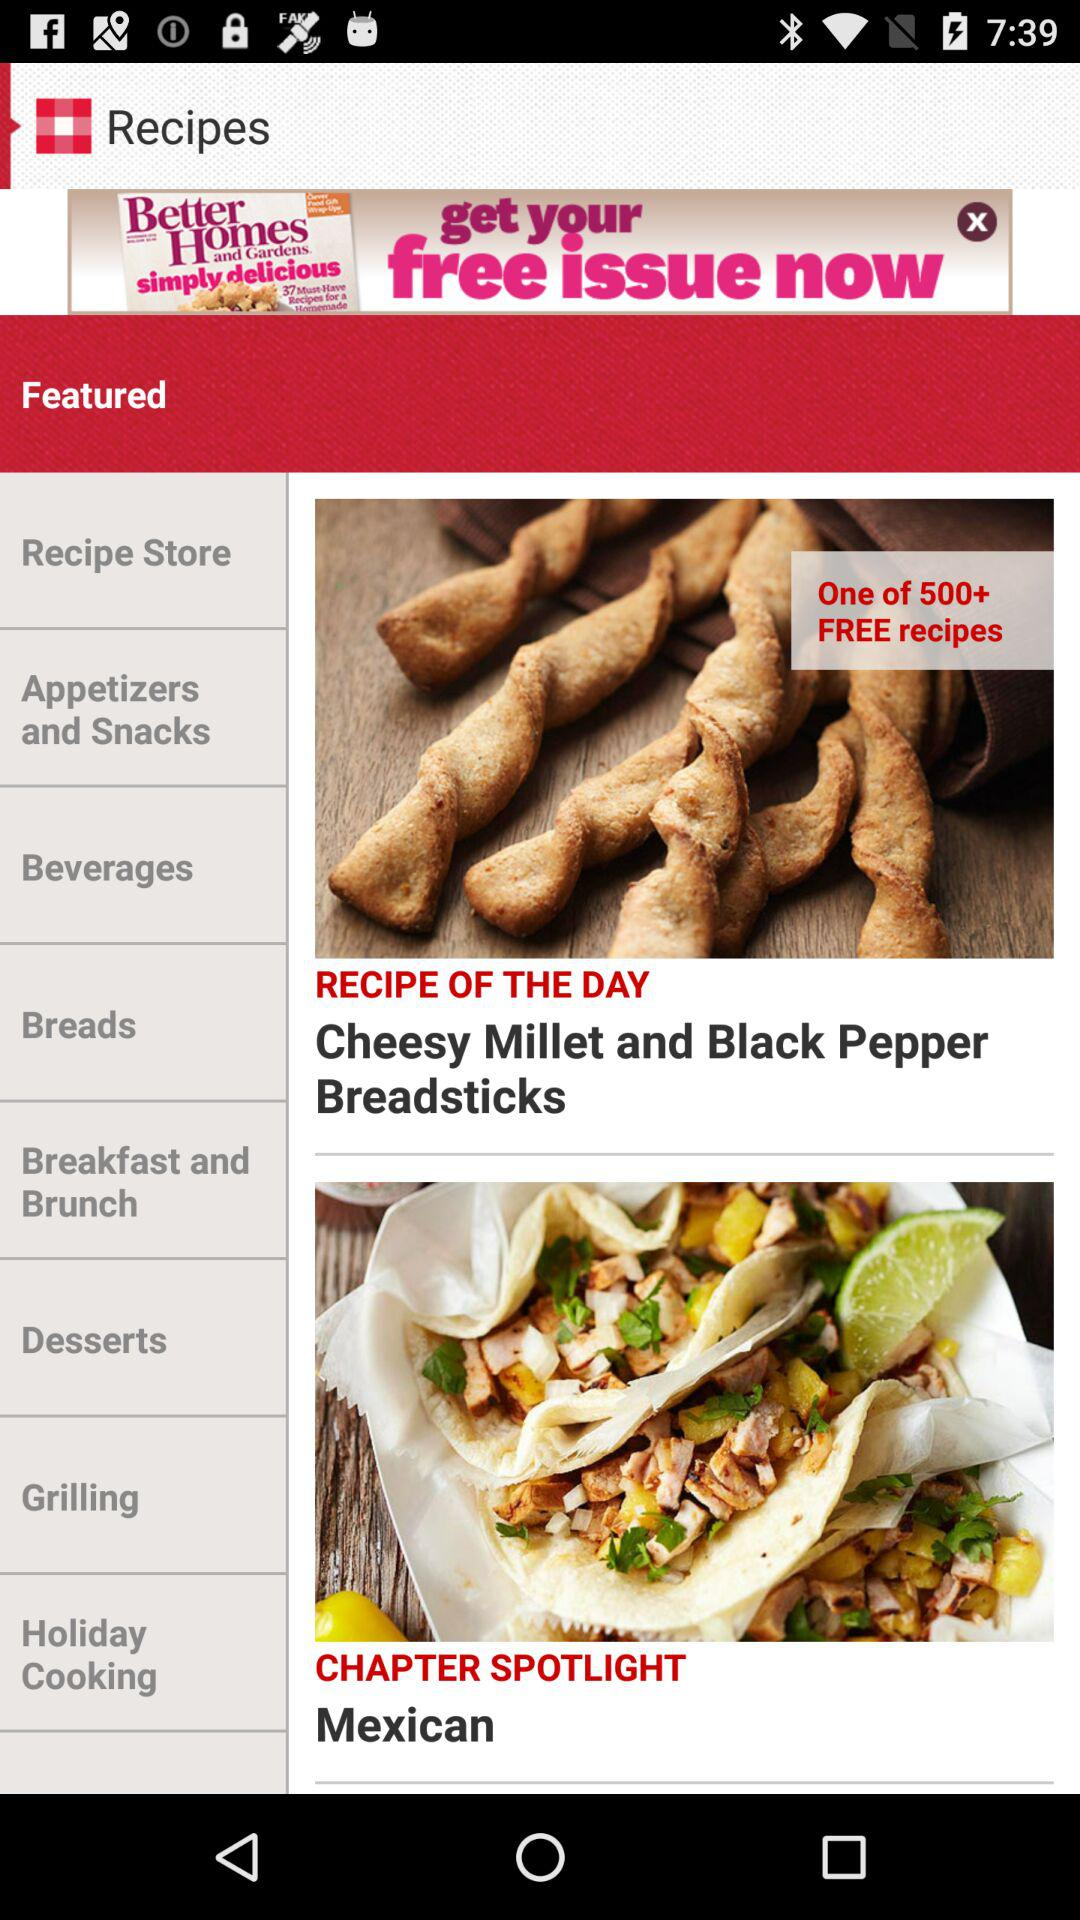Which recipe comes under chapter spotlight?
When the provided information is insufficient, respond with <no answer>. <no answer> 